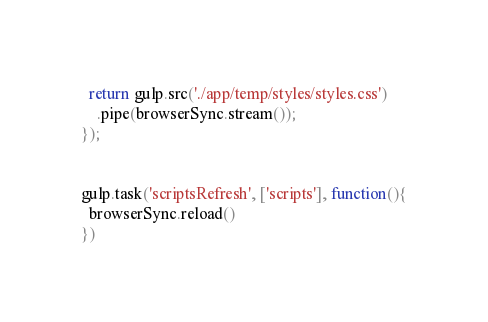<code> <loc_0><loc_0><loc_500><loc_500><_JavaScript_>  return gulp.src('./app/temp/styles/styles.css')
    .pipe(browserSync.stream());
});


gulp.task('scriptsRefresh', ['scripts'], function(){
  browserSync.reload()
})</code> 